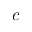Convert formula to latex. <formula><loc_0><loc_0><loc_500><loc_500>c</formula> 